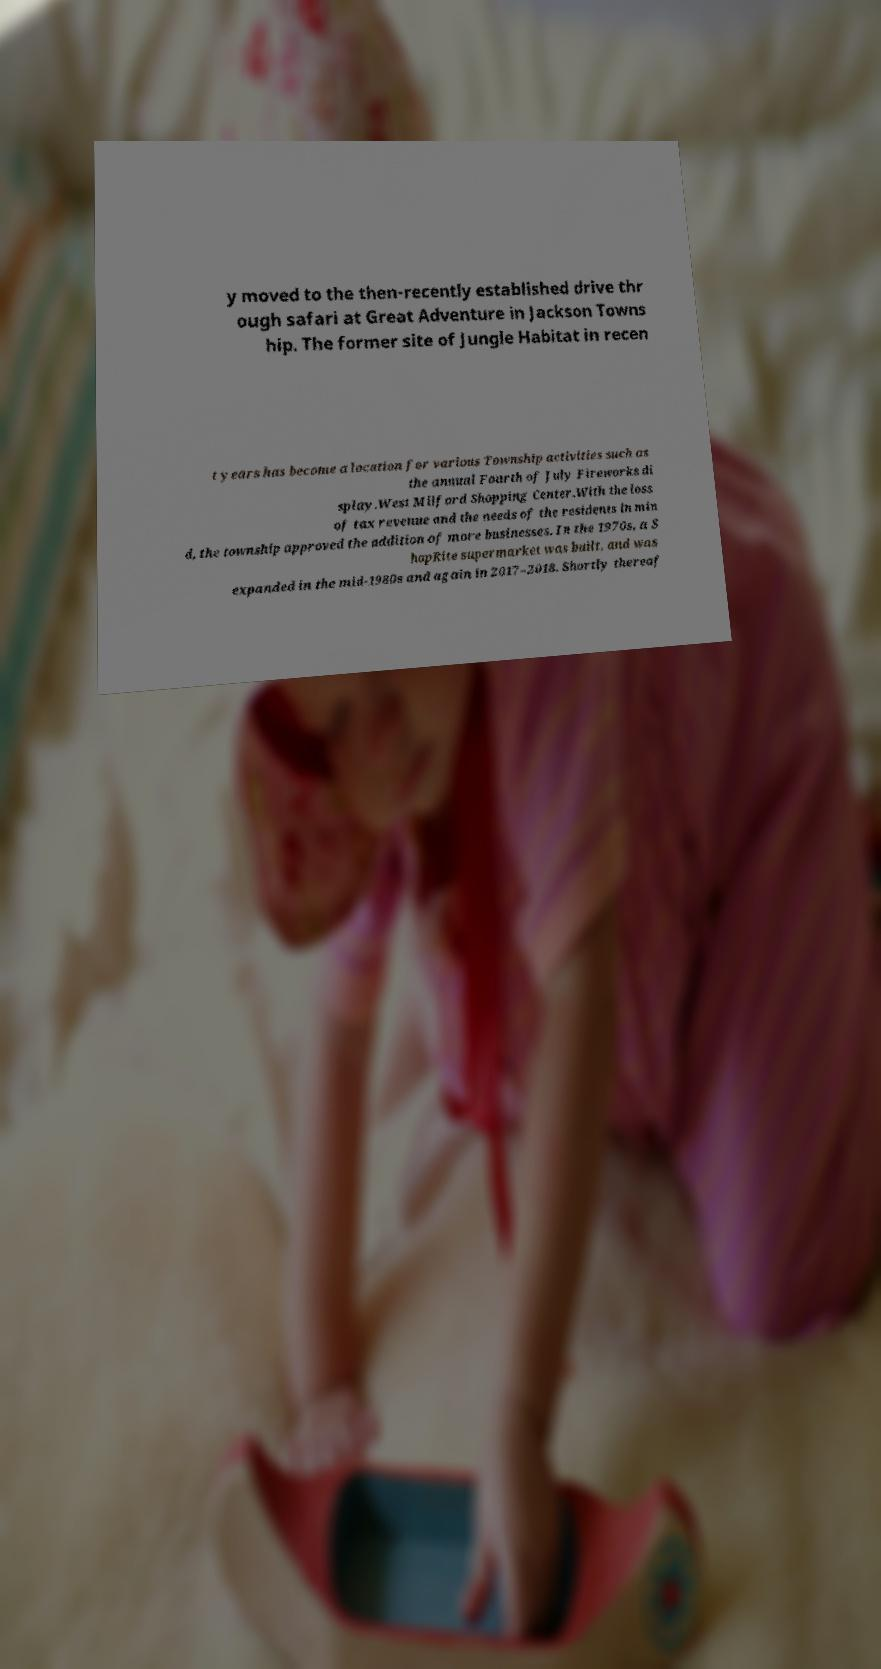Can you read and provide the text displayed in the image?This photo seems to have some interesting text. Can you extract and type it out for me? y moved to the then-recently established drive thr ough safari at Great Adventure in Jackson Towns hip. The former site of Jungle Habitat in recen t years has become a location for various Township activities such as the annual Fourth of July Fireworks di splay.West Milford Shopping Center.With the loss of tax revenue and the needs of the residents in min d, the township approved the addition of more businesses. In the 1970s, a S hopRite supermarket was built, and was expanded in the mid-1980s and again in 2017–2018. Shortly thereaf 